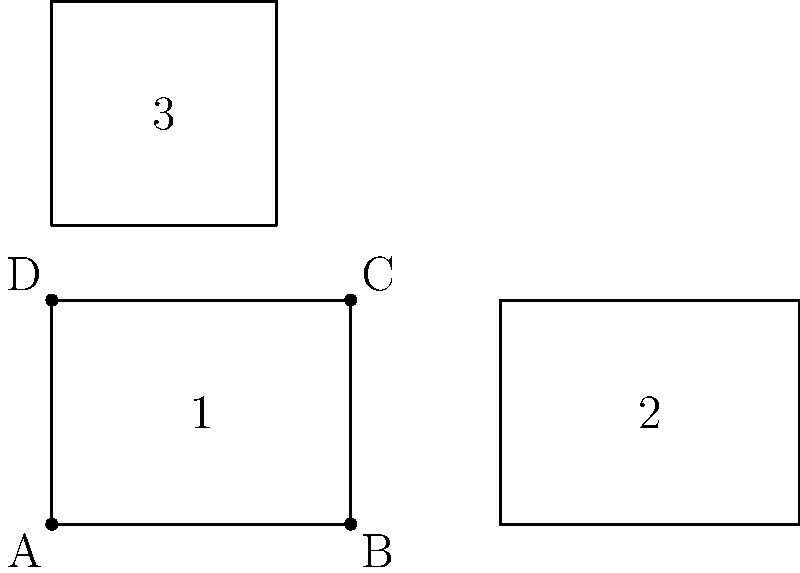In designing a digital flashcard app for language learning, you want to include a geometry component to teach spatial vocabulary. The app displays three rectangles as shown above. Which of these rectangles are congruent to each other, and how can this be used to reinforce language learning concepts? To determine which rectangles are congruent and how this can be used in language learning, let's follow these steps:

1. Recall the definition of congruent polygons: They have the same shape and size.

2. Analyze the rectangles:
   - Rectangle 1: 4 units wide, 3 units tall
   - Rectangle 2: 4 units wide, 3 units tall
   - Rectangle 3: 3 units wide, 3 units tall

3. Compare the rectangles:
   - Rectangles 1 and 2 have the same dimensions, so they are congruent.
   - Rectangle 3 has different dimensions, so it is not congruent to 1 and 2.

4. Application to language learning:
   - Use congruent shapes to teach vocabulary like "same," "identical," or "equal" in the target language.
   - Introduce comparative adjectives using non-congruent shapes (e.g., "wider," "taller," "smaller").
   - Practice spatial prepositions by describing the positions of the rectangles (e.g., "above," "below," "next to").
   - Reinforce number vocabulary by counting sides or comparing dimensions.
   - Introduce cultural elements by relating the shapes to architectural features or art from countries where the target language is spoken.

5. Technology integration:
   - Use interactive features to allow students to manipulate the shapes, reinforcing vocabulary through kinesthetic learning.
   - Implement voice recognition for students to practice pronunciation while describing the shapes.
   - Create matching exercises where students pair congruent shapes with corresponding vocabulary.
Answer: Rectangles 1 and 2 are congruent; use to teach same/different, comparatives, spatial prepositions, and numbers in target language. 